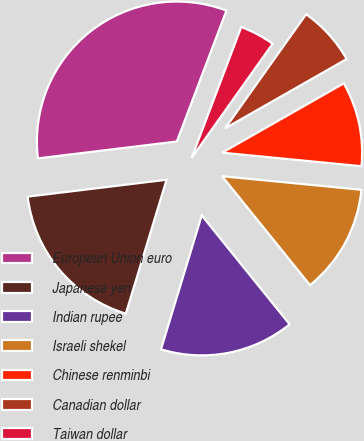Convert chart to OTSL. <chart><loc_0><loc_0><loc_500><loc_500><pie_chart><fcel>European Union euro<fcel>Japanese yen<fcel>Indian rupee<fcel>Israeli shekel<fcel>Chinese renminbi<fcel>Canadian dollar<fcel>Taiwan dollar<nl><fcel>32.69%<fcel>18.37%<fcel>15.51%<fcel>12.65%<fcel>9.79%<fcel>6.93%<fcel>4.06%<nl></chart> 